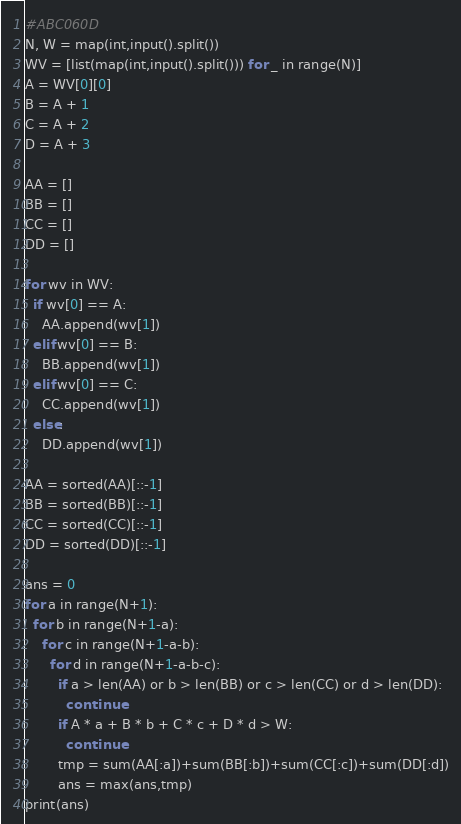Convert code to text. <code><loc_0><loc_0><loc_500><loc_500><_Python_>#ABC060D
N, W = map(int,input().split())
WV = [list(map(int,input().split())) for _ in range(N)]
A = WV[0][0]
B = A + 1
C = A + 2
D = A + 3

AA = []
BB = []
CC = []
DD = []

for wv in WV:
  if wv[0] == A:
    AA.append(wv[1])
  elif wv[0] == B:
    BB.append(wv[1])
  elif wv[0] == C:
    CC.append(wv[1])
  else:
    DD.append(wv[1])

AA = sorted(AA)[::-1]
BB = sorted(BB)[::-1]
CC = sorted(CC)[::-1]
DD = sorted(DD)[::-1]

ans = 0
for a in range(N+1):
  for b in range(N+1-a):
    for c in range(N+1-a-b):
      for d in range(N+1-a-b-c):
        if a > len(AA) or b > len(BB) or c > len(CC) or d > len(DD):
          continue
        if A * a + B * b + C * c + D * d > W:
          continue
        tmp = sum(AA[:a])+sum(BB[:b])+sum(CC[:c])+sum(DD[:d])
        ans = max(ans,tmp)
print(ans)</code> 